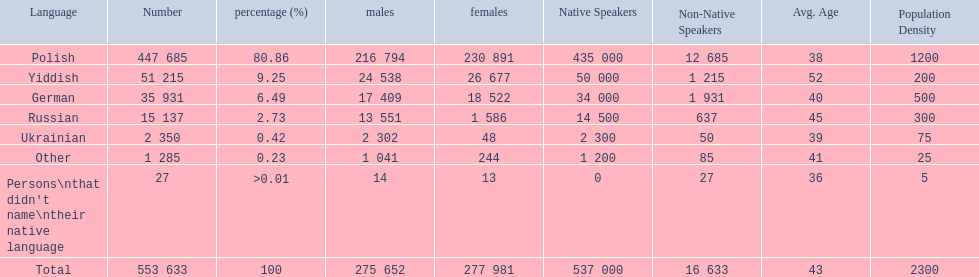What are all of the languages? Polish, Yiddish, German, Russian, Ukrainian, Other, Persons\nthat didn't name\ntheir native language. And how many people speak these languages? 447 685, 51 215, 35 931, 15 137, 2 350, 1 285, 27. Which language is used by most people? Polish. 